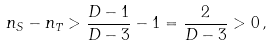<formula> <loc_0><loc_0><loc_500><loc_500>n _ { S } - n _ { T } > \frac { D - 1 } { D - 3 } - 1 = \frac { 2 } { D - 3 } > 0 \, ,</formula> 